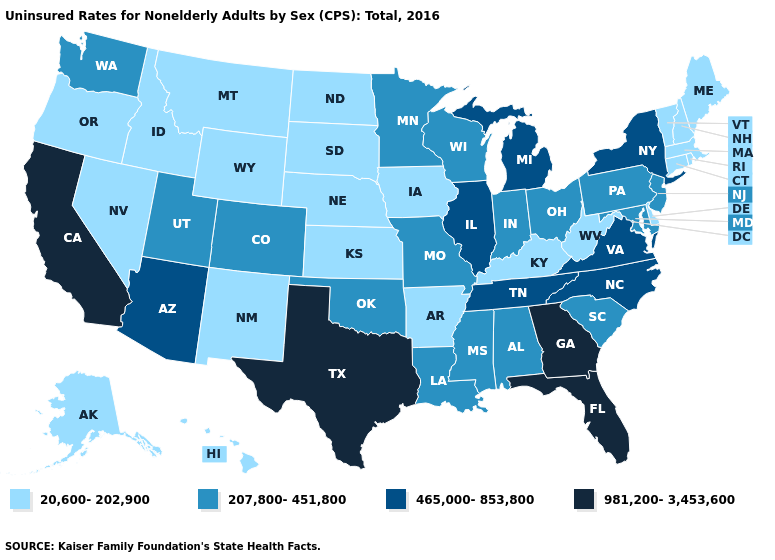What is the highest value in the West ?
Write a very short answer. 981,200-3,453,600. What is the value of Arizona?
Be succinct. 465,000-853,800. Does Delaware have the highest value in the USA?
Give a very brief answer. No. What is the value of Ohio?
Give a very brief answer. 207,800-451,800. What is the value of Rhode Island?
Be succinct. 20,600-202,900. Does Georgia have the highest value in the USA?
Quick response, please. Yes. What is the value of Texas?
Short answer required. 981,200-3,453,600. What is the value of Colorado?
Answer briefly. 207,800-451,800. Name the states that have a value in the range 20,600-202,900?
Answer briefly. Alaska, Arkansas, Connecticut, Delaware, Hawaii, Idaho, Iowa, Kansas, Kentucky, Maine, Massachusetts, Montana, Nebraska, Nevada, New Hampshire, New Mexico, North Dakota, Oregon, Rhode Island, South Dakota, Vermont, West Virginia, Wyoming. Name the states that have a value in the range 465,000-853,800?
Be succinct. Arizona, Illinois, Michigan, New York, North Carolina, Tennessee, Virginia. Does Louisiana have a lower value than Alabama?
Concise answer only. No. Among the states that border Nebraska , which have the lowest value?
Answer briefly. Iowa, Kansas, South Dakota, Wyoming. Name the states that have a value in the range 465,000-853,800?
Answer briefly. Arizona, Illinois, Michigan, New York, North Carolina, Tennessee, Virginia. Does the first symbol in the legend represent the smallest category?
Short answer required. Yes. What is the highest value in the USA?
Short answer required. 981,200-3,453,600. 